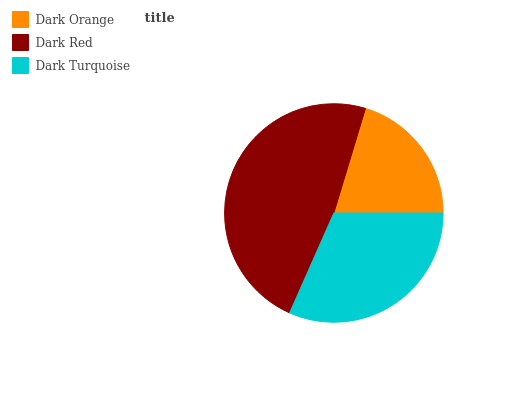Is Dark Orange the minimum?
Answer yes or no. Yes. Is Dark Red the maximum?
Answer yes or no. Yes. Is Dark Turquoise the minimum?
Answer yes or no. No. Is Dark Turquoise the maximum?
Answer yes or no. No. Is Dark Red greater than Dark Turquoise?
Answer yes or no. Yes. Is Dark Turquoise less than Dark Red?
Answer yes or no. Yes. Is Dark Turquoise greater than Dark Red?
Answer yes or no. No. Is Dark Red less than Dark Turquoise?
Answer yes or no. No. Is Dark Turquoise the high median?
Answer yes or no. Yes. Is Dark Turquoise the low median?
Answer yes or no. Yes. Is Dark Red the high median?
Answer yes or no. No. Is Dark Orange the low median?
Answer yes or no. No. 